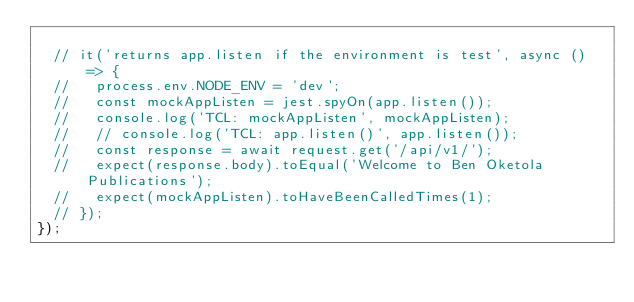Convert code to text. <code><loc_0><loc_0><loc_500><loc_500><_JavaScript_>
  // it('returns app.listen if the environment is test', async () => {
  //   process.env.NODE_ENV = 'dev';
  //   const mockAppListen = jest.spyOn(app.listen());
  //   console.log('TCL: mockAppListen', mockAppListen);
  //   // console.log('TCL: app.listen()', app.listen());
  //   const response = await request.get('/api/v1/');
  //   expect(response.body).toEqual('Welcome to Ben Oketola Publications');
  //   expect(mockAppListen).toHaveBeenCalledTimes(1);
  // });
});
</code> 